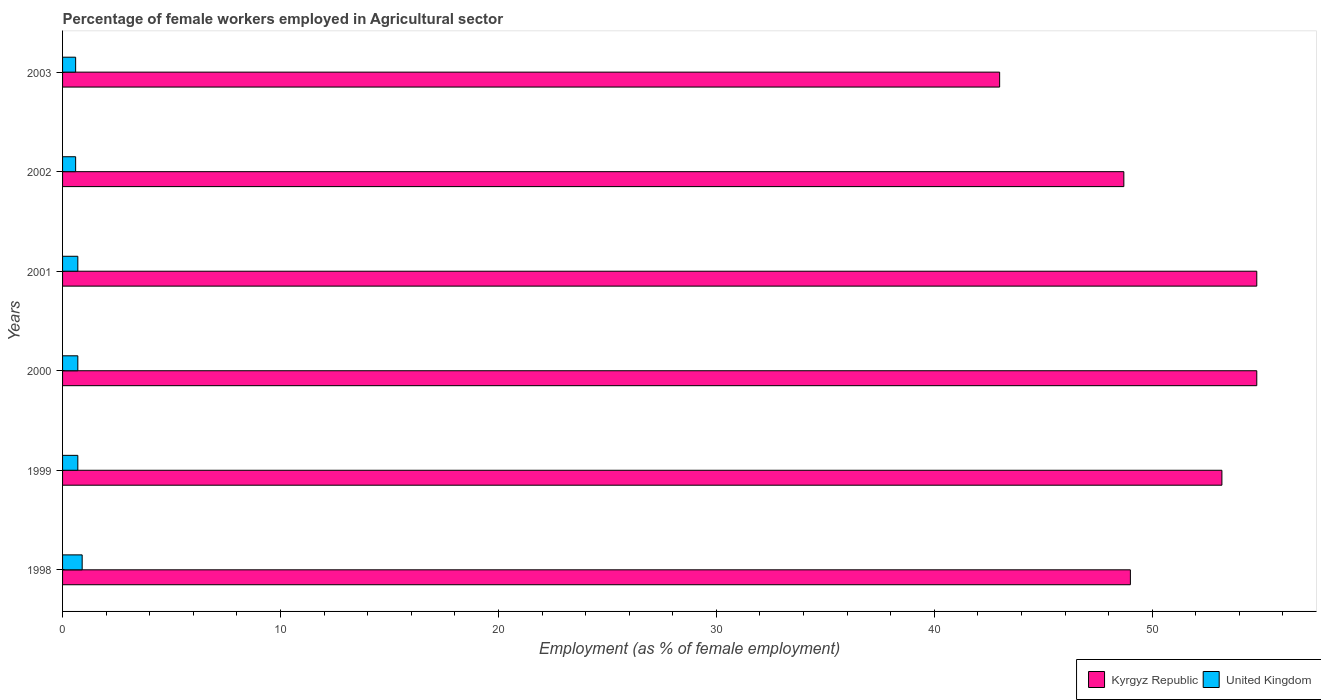How many groups of bars are there?
Offer a terse response. 6. Are the number of bars on each tick of the Y-axis equal?
Your answer should be very brief. Yes. What is the label of the 1st group of bars from the top?
Give a very brief answer. 2003. What is the percentage of females employed in Agricultural sector in United Kingdom in 2002?
Your response must be concise. 0.6. Across all years, what is the maximum percentage of females employed in Agricultural sector in Kyrgyz Republic?
Give a very brief answer. 54.8. What is the total percentage of females employed in Agricultural sector in United Kingdom in the graph?
Your answer should be very brief. 4.2. What is the difference between the percentage of females employed in Agricultural sector in United Kingdom in 1999 and that in 2001?
Make the answer very short. 0. What is the difference between the percentage of females employed in Agricultural sector in United Kingdom in 2000 and the percentage of females employed in Agricultural sector in Kyrgyz Republic in 1998?
Keep it short and to the point. -48.3. What is the average percentage of females employed in Agricultural sector in Kyrgyz Republic per year?
Give a very brief answer. 50.58. In the year 2002, what is the difference between the percentage of females employed in Agricultural sector in Kyrgyz Republic and percentage of females employed in Agricultural sector in United Kingdom?
Provide a succinct answer. 48.1. In how many years, is the percentage of females employed in Agricultural sector in United Kingdom greater than 24 %?
Offer a terse response. 0. What is the ratio of the percentage of females employed in Agricultural sector in Kyrgyz Republic in 2001 to that in 2002?
Keep it short and to the point. 1.13. Is the percentage of females employed in Agricultural sector in Kyrgyz Republic in 1998 less than that in 1999?
Provide a short and direct response. Yes. Is the difference between the percentage of females employed in Agricultural sector in Kyrgyz Republic in 1998 and 2003 greater than the difference between the percentage of females employed in Agricultural sector in United Kingdom in 1998 and 2003?
Provide a succinct answer. Yes. What is the difference between the highest and the second highest percentage of females employed in Agricultural sector in United Kingdom?
Your response must be concise. 0.2. What is the difference between the highest and the lowest percentage of females employed in Agricultural sector in Kyrgyz Republic?
Provide a short and direct response. 11.8. Is the sum of the percentage of females employed in Agricultural sector in Kyrgyz Republic in 1998 and 2002 greater than the maximum percentage of females employed in Agricultural sector in United Kingdom across all years?
Give a very brief answer. Yes. What does the 2nd bar from the top in 1999 represents?
Your answer should be compact. Kyrgyz Republic. What does the 1st bar from the bottom in 1998 represents?
Provide a short and direct response. Kyrgyz Republic. What is the difference between two consecutive major ticks on the X-axis?
Offer a terse response. 10. Are the values on the major ticks of X-axis written in scientific E-notation?
Your answer should be very brief. No. Does the graph contain any zero values?
Your answer should be very brief. No. Does the graph contain grids?
Make the answer very short. No. How many legend labels are there?
Offer a terse response. 2. What is the title of the graph?
Make the answer very short. Percentage of female workers employed in Agricultural sector. What is the label or title of the X-axis?
Offer a terse response. Employment (as % of female employment). What is the Employment (as % of female employment) of Kyrgyz Republic in 1998?
Your response must be concise. 49. What is the Employment (as % of female employment) of United Kingdom in 1998?
Your answer should be compact. 0.9. What is the Employment (as % of female employment) in Kyrgyz Republic in 1999?
Ensure brevity in your answer.  53.2. What is the Employment (as % of female employment) of United Kingdom in 1999?
Keep it short and to the point. 0.7. What is the Employment (as % of female employment) in Kyrgyz Republic in 2000?
Your answer should be compact. 54.8. What is the Employment (as % of female employment) of United Kingdom in 2000?
Offer a very short reply. 0.7. What is the Employment (as % of female employment) in Kyrgyz Republic in 2001?
Provide a short and direct response. 54.8. What is the Employment (as % of female employment) in United Kingdom in 2001?
Give a very brief answer. 0.7. What is the Employment (as % of female employment) in Kyrgyz Republic in 2002?
Your answer should be very brief. 48.7. What is the Employment (as % of female employment) in United Kingdom in 2002?
Give a very brief answer. 0.6. What is the Employment (as % of female employment) of Kyrgyz Republic in 2003?
Your answer should be very brief. 43. What is the Employment (as % of female employment) in United Kingdom in 2003?
Keep it short and to the point. 0.6. Across all years, what is the maximum Employment (as % of female employment) in Kyrgyz Republic?
Make the answer very short. 54.8. Across all years, what is the maximum Employment (as % of female employment) in United Kingdom?
Ensure brevity in your answer.  0.9. Across all years, what is the minimum Employment (as % of female employment) of Kyrgyz Republic?
Give a very brief answer. 43. Across all years, what is the minimum Employment (as % of female employment) of United Kingdom?
Your response must be concise. 0.6. What is the total Employment (as % of female employment) in Kyrgyz Republic in the graph?
Your answer should be compact. 303.5. What is the total Employment (as % of female employment) of United Kingdom in the graph?
Ensure brevity in your answer.  4.2. What is the difference between the Employment (as % of female employment) of Kyrgyz Republic in 1998 and that in 1999?
Provide a short and direct response. -4.2. What is the difference between the Employment (as % of female employment) in United Kingdom in 1998 and that in 1999?
Offer a very short reply. 0.2. What is the difference between the Employment (as % of female employment) of United Kingdom in 1998 and that in 2000?
Your answer should be compact. 0.2. What is the difference between the Employment (as % of female employment) of Kyrgyz Republic in 1998 and that in 2001?
Your answer should be very brief. -5.8. What is the difference between the Employment (as % of female employment) in Kyrgyz Republic in 1998 and that in 2002?
Ensure brevity in your answer.  0.3. What is the difference between the Employment (as % of female employment) in United Kingdom in 1998 and that in 2002?
Keep it short and to the point. 0.3. What is the difference between the Employment (as % of female employment) of Kyrgyz Republic in 1998 and that in 2003?
Your response must be concise. 6. What is the difference between the Employment (as % of female employment) of United Kingdom in 1998 and that in 2003?
Provide a succinct answer. 0.3. What is the difference between the Employment (as % of female employment) in United Kingdom in 1999 and that in 2000?
Your response must be concise. 0. What is the difference between the Employment (as % of female employment) of Kyrgyz Republic in 1999 and that in 2001?
Offer a terse response. -1.6. What is the difference between the Employment (as % of female employment) of United Kingdom in 1999 and that in 2001?
Keep it short and to the point. 0. What is the difference between the Employment (as % of female employment) of Kyrgyz Republic in 1999 and that in 2002?
Make the answer very short. 4.5. What is the difference between the Employment (as % of female employment) in United Kingdom in 2000 and that in 2001?
Make the answer very short. 0. What is the difference between the Employment (as % of female employment) in Kyrgyz Republic in 2000 and that in 2002?
Keep it short and to the point. 6.1. What is the difference between the Employment (as % of female employment) in United Kingdom in 2000 and that in 2003?
Your response must be concise. 0.1. What is the difference between the Employment (as % of female employment) in Kyrgyz Republic in 2001 and that in 2002?
Ensure brevity in your answer.  6.1. What is the difference between the Employment (as % of female employment) in United Kingdom in 2001 and that in 2002?
Your answer should be very brief. 0.1. What is the difference between the Employment (as % of female employment) of United Kingdom in 2001 and that in 2003?
Keep it short and to the point. 0.1. What is the difference between the Employment (as % of female employment) in United Kingdom in 2002 and that in 2003?
Your answer should be very brief. 0. What is the difference between the Employment (as % of female employment) in Kyrgyz Republic in 1998 and the Employment (as % of female employment) in United Kingdom in 1999?
Provide a succinct answer. 48.3. What is the difference between the Employment (as % of female employment) of Kyrgyz Republic in 1998 and the Employment (as % of female employment) of United Kingdom in 2000?
Offer a terse response. 48.3. What is the difference between the Employment (as % of female employment) in Kyrgyz Republic in 1998 and the Employment (as % of female employment) in United Kingdom in 2001?
Your response must be concise. 48.3. What is the difference between the Employment (as % of female employment) in Kyrgyz Republic in 1998 and the Employment (as % of female employment) in United Kingdom in 2002?
Offer a very short reply. 48.4. What is the difference between the Employment (as % of female employment) of Kyrgyz Republic in 1998 and the Employment (as % of female employment) of United Kingdom in 2003?
Give a very brief answer. 48.4. What is the difference between the Employment (as % of female employment) of Kyrgyz Republic in 1999 and the Employment (as % of female employment) of United Kingdom in 2000?
Ensure brevity in your answer.  52.5. What is the difference between the Employment (as % of female employment) in Kyrgyz Republic in 1999 and the Employment (as % of female employment) in United Kingdom in 2001?
Make the answer very short. 52.5. What is the difference between the Employment (as % of female employment) of Kyrgyz Republic in 1999 and the Employment (as % of female employment) of United Kingdom in 2002?
Your response must be concise. 52.6. What is the difference between the Employment (as % of female employment) in Kyrgyz Republic in 1999 and the Employment (as % of female employment) in United Kingdom in 2003?
Your answer should be very brief. 52.6. What is the difference between the Employment (as % of female employment) in Kyrgyz Republic in 2000 and the Employment (as % of female employment) in United Kingdom in 2001?
Keep it short and to the point. 54.1. What is the difference between the Employment (as % of female employment) in Kyrgyz Republic in 2000 and the Employment (as % of female employment) in United Kingdom in 2002?
Ensure brevity in your answer.  54.2. What is the difference between the Employment (as % of female employment) of Kyrgyz Republic in 2000 and the Employment (as % of female employment) of United Kingdom in 2003?
Make the answer very short. 54.2. What is the difference between the Employment (as % of female employment) of Kyrgyz Republic in 2001 and the Employment (as % of female employment) of United Kingdom in 2002?
Give a very brief answer. 54.2. What is the difference between the Employment (as % of female employment) in Kyrgyz Republic in 2001 and the Employment (as % of female employment) in United Kingdom in 2003?
Offer a very short reply. 54.2. What is the difference between the Employment (as % of female employment) in Kyrgyz Republic in 2002 and the Employment (as % of female employment) in United Kingdom in 2003?
Offer a terse response. 48.1. What is the average Employment (as % of female employment) of Kyrgyz Republic per year?
Provide a succinct answer. 50.58. What is the average Employment (as % of female employment) in United Kingdom per year?
Provide a short and direct response. 0.7. In the year 1998, what is the difference between the Employment (as % of female employment) in Kyrgyz Republic and Employment (as % of female employment) in United Kingdom?
Ensure brevity in your answer.  48.1. In the year 1999, what is the difference between the Employment (as % of female employment) of Kyrgyz Republic and Employment (as % of female employment) of United Kingdom?
Make the answer very short. 52.5. In the year 2000, what is the difference between the Employment (as % of female employment) of Kyrgyz Republic and Employment (as % of female employment) of United Kingdom?
Provide a succinct answer. 54.1. In the year 2001, what is the difference between the Employment (as % of female employment) in Kyrgyz Republic and Employment (as % of female employment) in United Kingdom?
Offer a very short reply. 54.1. In the year 2002, what is the difference between the Employment (as % of female employment) in Kyrgyz Republic and Employment (as % of female employment) in United Kingdom?
Provide a succinct answer. 48.1. In the year 2003, what is the difference between the Employment (as % of female employment) of Kyrgyz Republic and Employment (as % of female employment) of United Kingdom?
Ensure brevity in your answer.  42.4. What is the ratio of the Employment (as % of female employment) of Kyrgyz Republic in 1998 to that in 1999?
Keep it short and to the point. 0.92. What is the ratio of the Employment (as % of female employment) of Kyrgyz Republic in 1998 to that in 2000?
Offer a terse response. 0.89. What is the ratio of the Employment (as % of female employment) in Kyrgyz Republic in 1998 to that in 2001?
Give a very brief answer. 0.89. What is the ratio of the Employment (as % of female employment) of United Kingdom in 1998 to that in 2001?
Ensure brevity in your answer.  1.29. What is the ratio of the Employment (as % of female employment) of Kyrgyz Republic in 1998 to that in 2002?
Provide a succinct answer. 1.01. What is the ratio of the Employment (as % of female employment) of United Kingdom in 1998 to that in 2002?
Your answer should be very brief. 1.5. What is the ratio of the Employment (as % of female employment) of Kyrgyz Republic in 1998 to that in 2003?
Your answer should be compact. 1.14. What is the ratio of the Employment (as % of female employment) in United Kingdom in 1998 to that in 2003?
Provide a succinct answer. 1.5. What is the ratio of the Employment (as % of female employment) in Kyrgyz Republic in 1999 to that in 2000?
Make the answer very short. 0.97. What is the ratio of the Employment (as % of female employment) of Kyrgyz Republic in 1999 to that in 2001?
Make the answer very short. 0.97. What is the ratio of the Employment (as % of female employment) of United Kingdom in 1999 to that in 2001?
Offer a very short reply. 1. What is the ratio of the Employment (as % of female employment) in Kyrgyz Republic in 1999 to that in 2002?
Provide a succinct answer. 1.09. What is the ratio of the Employment (as % of female employment) of United Kingdom in 1999 to that in 2002?
Keep it short and to the point. 1.17. What is the ratio of the Employment (as % of female employment) in Kyrgyz Republic in 1999 to that in 2003?
Ensure brevity in your answer.  1.24. What is the ratio of the Employment (as % of female employment) in Kyrgyz Republic in 2000 to that in 2001?
Ensure brevity in your answer.  1. What is the ratio of the Employment (as % of female employment) of Kyrgyz Republic in 2000 to that in 2002?
Offer a very short reply. 1.13. What is the ratio of the Employment (as % of female employment) in Kyrgyz Republic in 2000 to that in 2003?
Offer a very short reply. 1.27. What is the ratio of the Employment (as % of female employment) in United Kingdom in 2000 to that in 2003?
Make the answer very short. 1.17. What is the ratio of the Employment (as % of female employment) of Kyrgyz Republic in 2001 to that in 2002?
Provide a short and direct response. 1.13. What is the ratio of the Employment (as % of female employment) of Kyrgyz Republic in 2001 to that in 2003?
Provide a short and direct response. 1.27. What is the ratio of the Employment (as % of female employment) of United Kingdom in 2001 to that in 2003?
Make the answer very short. 1.17. What is the ratio of the Employment (as % of female employment) in Kyrgyz Republic in 2002 to that in 2003?
Keep it short and to the point. 1.13. What is the ratio of the Employment (as % of female employment) of United Kingdom in 2002 to that in 2003?
Provide a succinct answer. 1. 